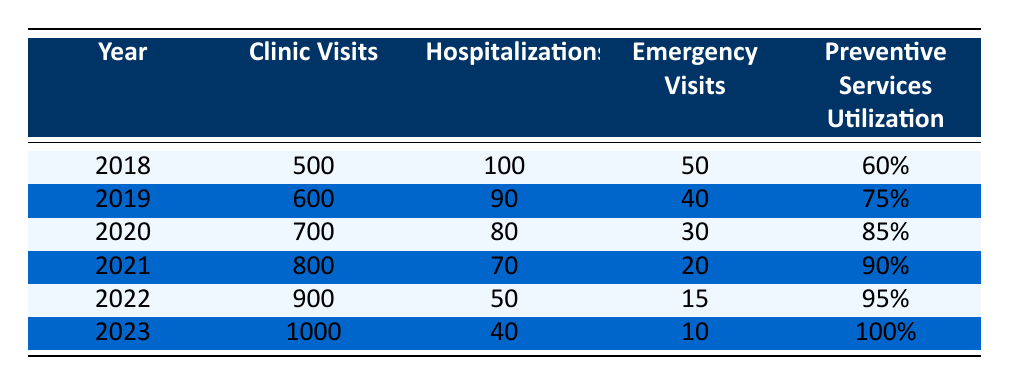What was the total number of clinic visits from 2018 to 2023? To find the total number of clinic visits, I will sum the values for each year. The values are: 500 (2018) + 600 (2019) + 700 (2020) + 800 (2021) + 900 (2022) + 1000 (2023) = 4000.
Answer: 4000 What was the percentage decrease in hospitalizations from 2018 to 2023? To calculate the percentage decrease, I first find the difference in hospitalizations from 100 (2018) to 40 (2023), which is 100 - 40 = 60. Then, I divide the difference by the original number (100) and multiply by 100: (60 / 100) * 100 = 60%.
Answer: 60% How many emergency visits were recorded in 2020? The table shows that there were 30 emergency visits recorded in 2020.
Answer: 30 Was there an increase in preventive services utilization from 2019 to 2020? To determine if there was an increase, I compare the values from 2019 (75%) to 2020 (85%). Since 85% is greater than 75%, there was an increase.
Answer: Yes What was the average number of hospitalizations over the years presented? The number of hospitalizations per year is: 100, 90, 80, 70, 50, and 40. I will sum these values: 100 + 90 + 80 + 70 + 50 + 40 = 430. There are 6 years in total, so the average is 430 / 6 = approximately 71.67.
Answer: Approximately 71.67 How many more clinic visits were there in 2022 than in 2018? The number of clinic visits in 2022 (900) minus the number of clinic visits in 2018 (500) equals 900 - 500 = 400.
Answer: 400 Did the emergency visits decrease every year from 2018 to 2023? I will examine the values for each year: 50 (2018), 40 (2019), 30 (2020), 20 (2021), 15 (2022), and 10 (2023). Since all values decreased from one year to the next, this statement is true.
Answer: Yes What is the trend in preventive services utilization from 2018 to 2023? The values for preventive services utilization are: 60% (2018), 75% (2019), 85% (2020), 90% (2021), 95% (2022), and 100% (2023). Each year shows an increase, indicating a positive trend.
Answer: Increasing 